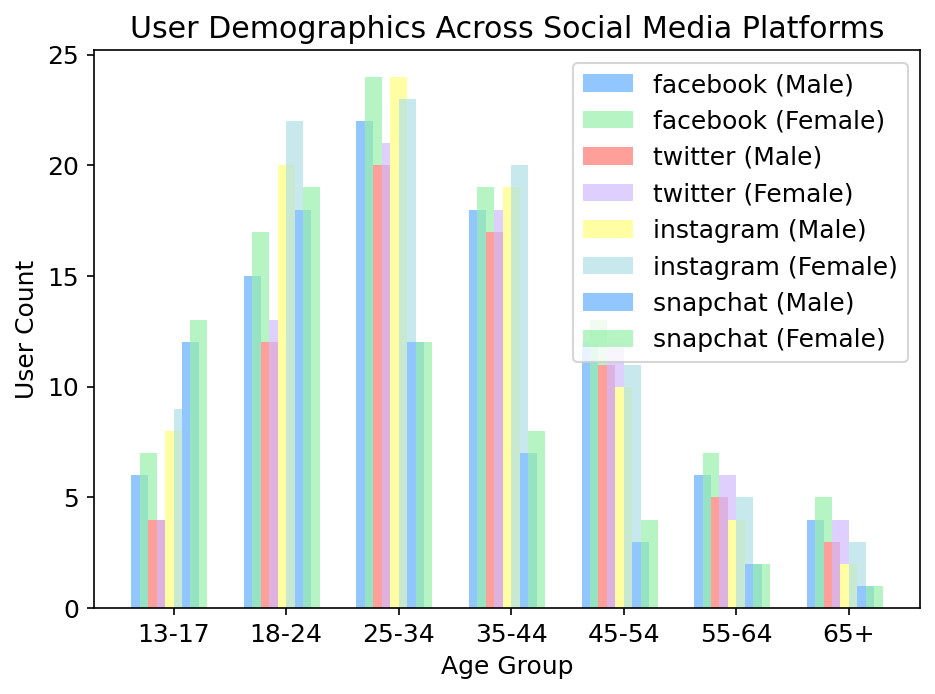Which age group has the highest number of female users on Snapchat? Identify the Female Snapchat bars and compare their heights. The 13-17 age group has the highest bar.
Answer: 13-17 Which platform has the smallest difference in the number of male and female users across all age groups? Calculate the differences between male and female users for each platform. For example, Facebook has differences like 2 (18-24), 2 (25-34), etc. Compare these differences. Instagram has the smallest differences across all age groups.
Answer: Instagram Which age group shows an equal count of male and female users on Facebook? Compare the heights of the Facebook bars for both genders in each age group. The 25-34 age group has bars of almost the same height.
Answer: 25-34 How many more female users in the 18-24 age group use Instagram compared to Twitter? Subtract the number of female Twitter users from the number of female Instagram users in the 18-24 age group: 22 - 13 = 9.
Answer: 9 What is the highest number of male users for any platform and age group combination? Check all the bars for male users and find the highest one. The highest is 24 for ages 25-34 on Instagram.
Answer: 24 Which platform has the most balanced gender distribution in the 45-54 age group? Compare the male and female bars for each platform in the 45-54 age group. Twitter has nearly similar heights for both genders in this age group.
Answer: Twitter What is the average number of female users across all platforms in the 35-44 age group? Sum the number of female users for all platforms in the 35-44 age group and divide by the number of platforms: (19 + 18 + 20 + 8)/4 = 16.25.
Answer: 16.25 Which platform do males in the 13-17 age group use the least? Identify the shortest bar for males in the 13-17 age group. Twitter shows the smallest bar.
Answer: Twitter Between the 55-64 age group and the 65+ age group, which has more total Instagram users? Calculate the total Instagram users in each age group. For 55-64: 4 (M) + 5 (F) = 9. For 65+: 2 (M) + 3 (F) = 5. 55-64 has more users.
Answer: 55-64 Can you identify any clear trends in social media usage among younger versus older age groups? Younger age groups (13-24) show higher bar heights across all platforms, indicating more usage compared to age groups 55 and older, which have significantly lower bars. This suggests younger users are more active on social media.
Answer: Younger users are more active 